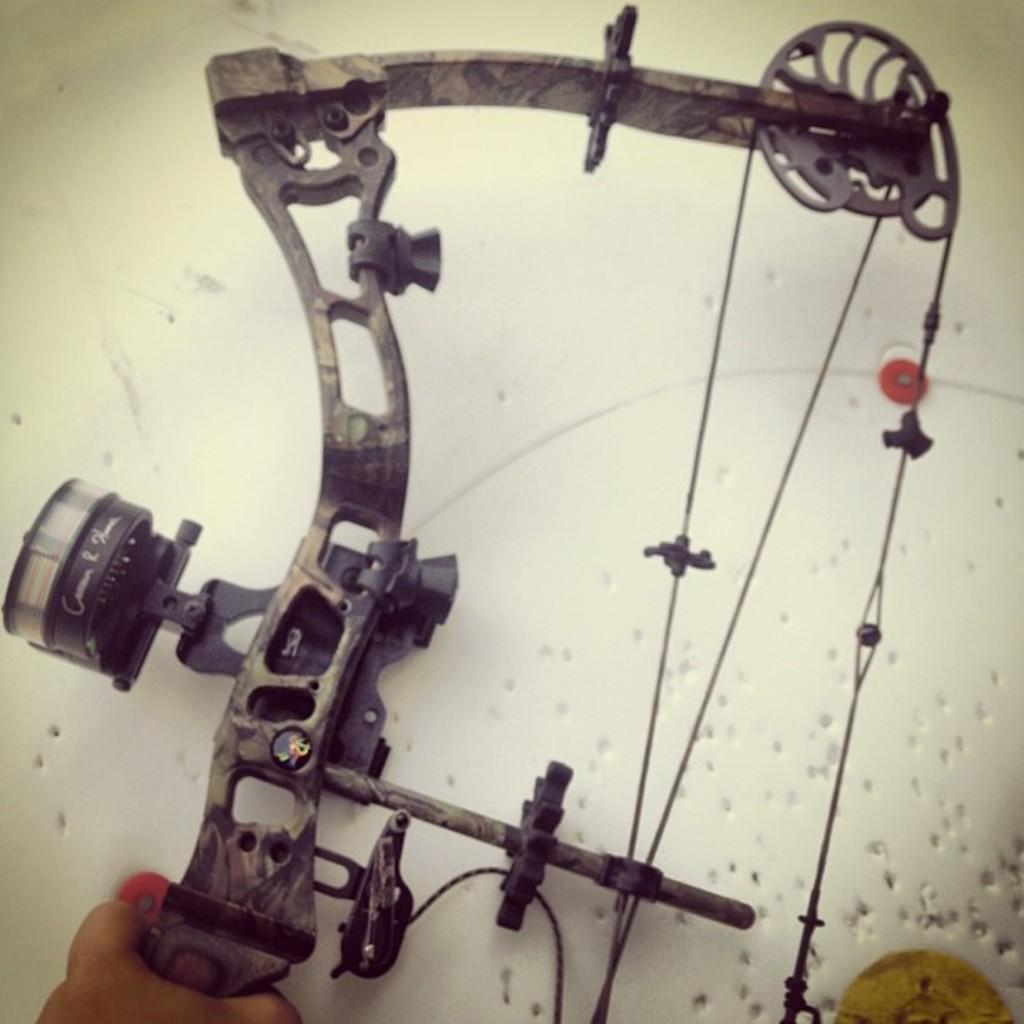Describe this image in one or two sentences. In this image we can see a machine. There is white background with holes. There is a person's hand. 